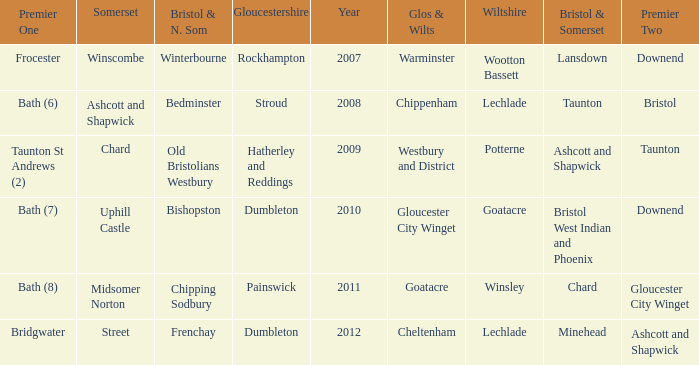What is the year where glos & wilts is gloucester city winget? 2010.0. 